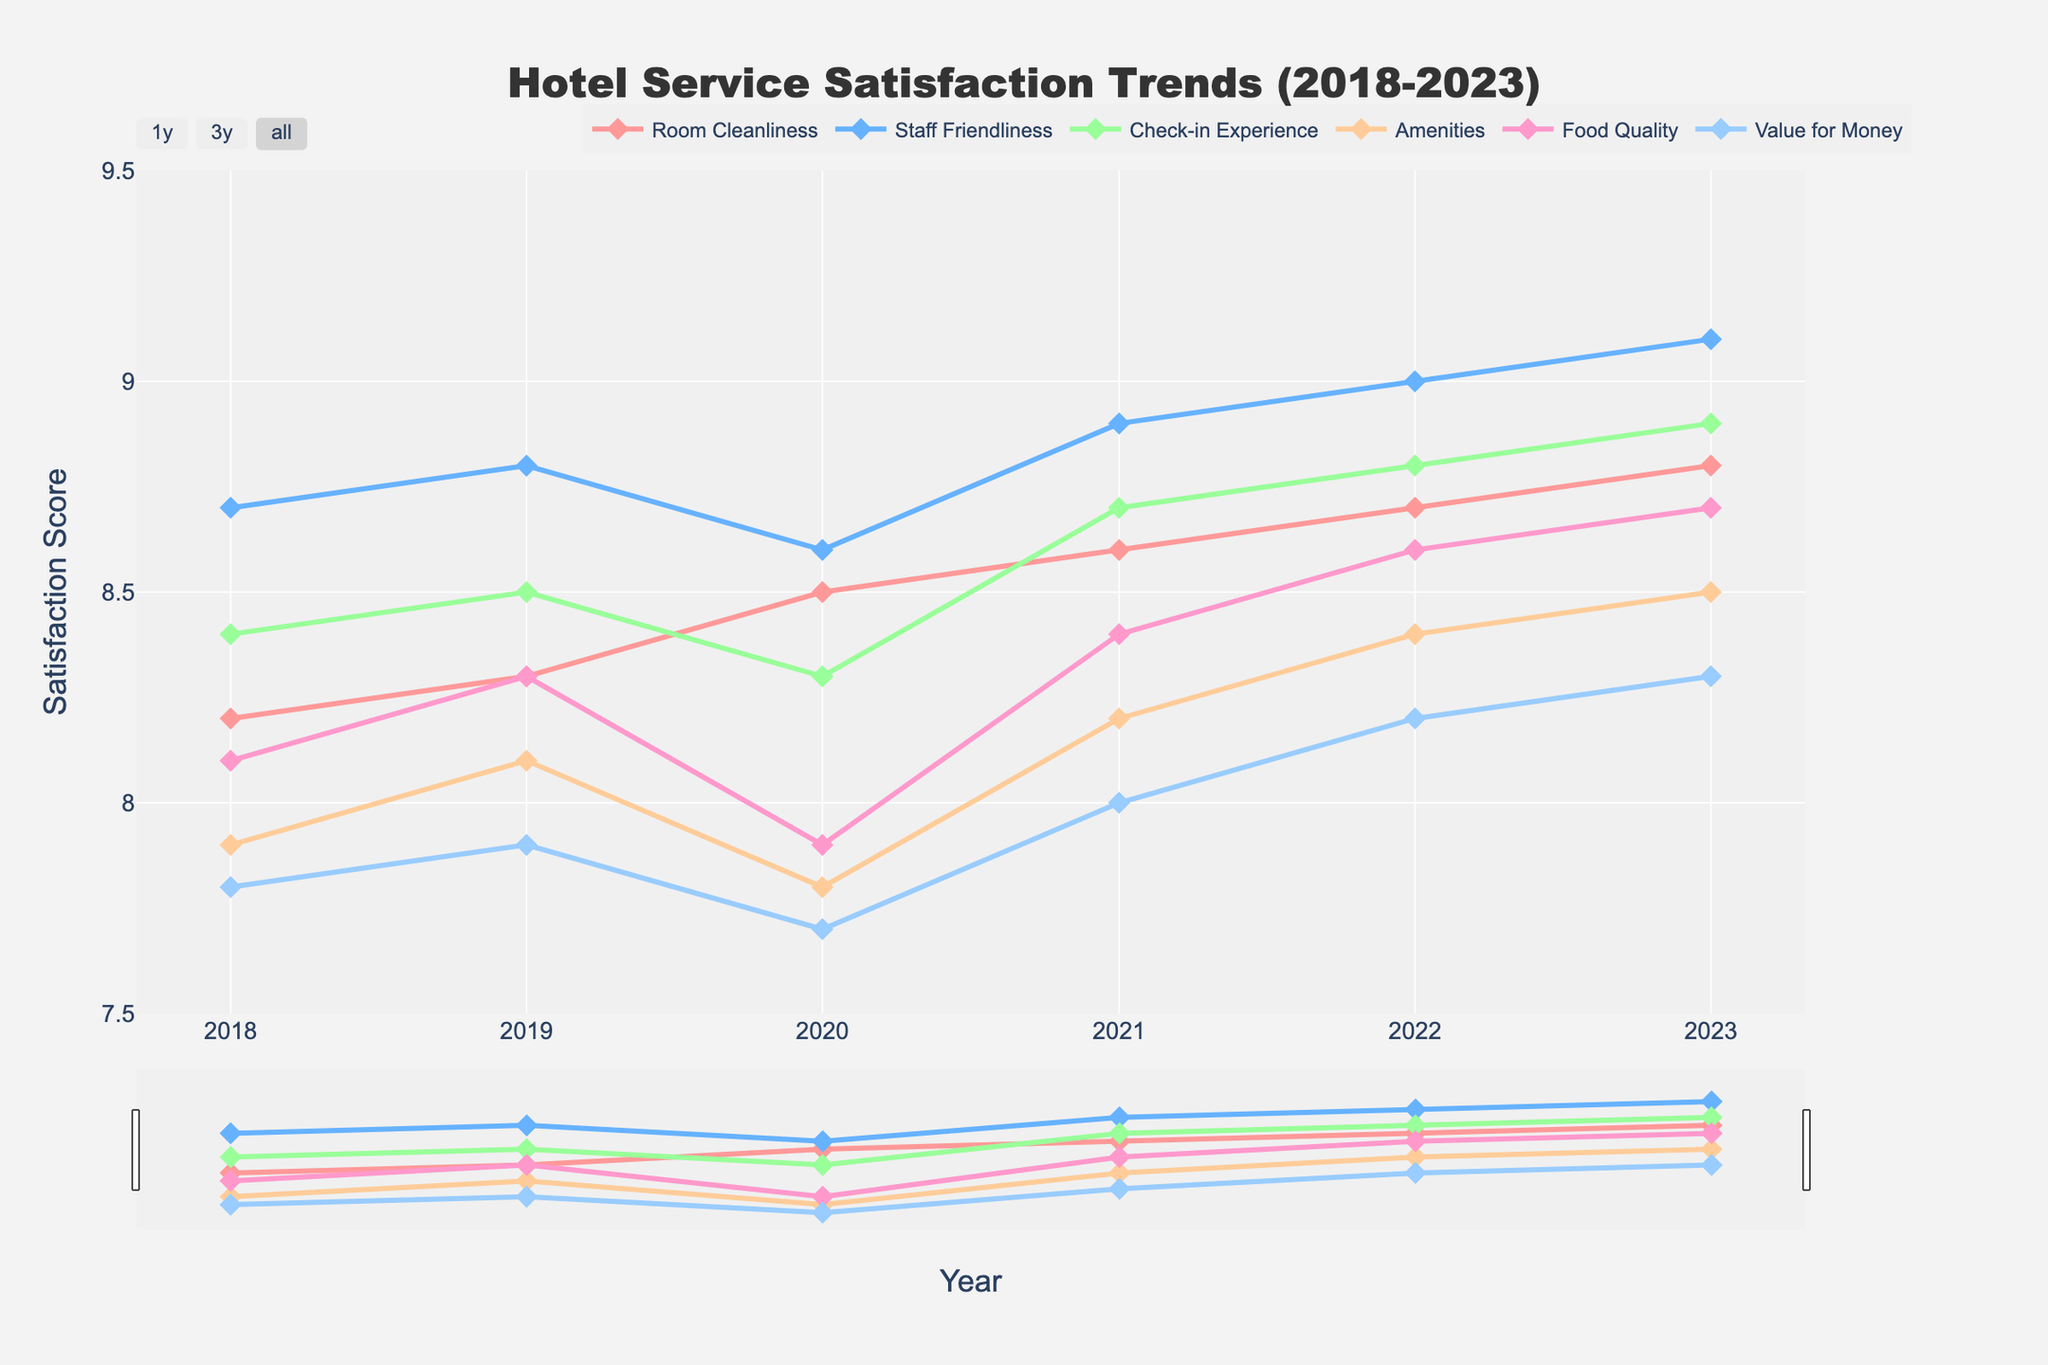How has the satisfaction score for "Room Cleanliness" changed from 2018 to 2023? To find out how the satisfaction score for "Room Cleanliness" has changed, refer to the data points for this aspect from 2018 to 2023. In 2018, the score was 8.2, and by 2023, it had increased to 8.8.
Answer: The satisfaction score for "Room Cleanliness" has increased from 8.2 to 8.8 Which aspect of hotel service had the highest satisfaction score in 2023? Look at the scores for all aspects in the year 2023. The scores are: Room Cleanliness (8.8), Staff Friendliness (9.1), Check-in Experience (8.9), Amenities (8.5), Food Quality (8.7), and Value for Money (8.3). The highest score is 9.1 for "Staff Friendliness".
Answer: Staff Friendliness What is the average satisfaction score for "Food Quality" over the years 2018 to 2023? Add the yearly satisfaction scores for "Food Quality" and divide by the number of years. The scores are: 8.1 (2018), 8.3 (2019), 7.9 (2020), 8.4 (2021), 8.6 (2022), and 8.7 (2023). The sum is 50 and there are 6 years: 50/6 = 8.33.
Answer: 8.33 Did the satisfaction score for "Value for Money" ever decrease compared to the previous year? Check the scores for "Value for Money" year by year to see if any score is lower than the previous year's score. The scores are: 7.8 (2018), 7.9 (2019), 7.7 (2020), 8.0 (2021), 8.2 (2022), 8.3 (2023). The score decreased from 7.9 in 2019 to 7.7 in 2020.
Answer: Yes, it decreased in 2020 Which year saw the greatest improvement in "Check-in Experience"? To determine the greatest improvement, calculate the year-over-year changes for "Check-in Experience". The changes are: (8.5 - 8.4) = 0.1 (2019), (8.3 - 8.5) = -0.2 (2020), (8.7 - 8.3) = 0.4 (2021), (8.8 - 8.7) = 0.1 (2022), (8.9 - 8.8) = 0.1 (2023). The greatest improvement is 0.4 in 2021.
Answer: 2021 Compare the trend for "Staff Friendliness" with that of "Amenities" from 2018 to 2023. Observe both trends over the given years. "Staff Friendliness" shows consistent improvement from 8.7 to 9.1 while "Amenities" fluctuates, starting at 7.9, increasing to 8.4 by 2022, and slightly increasing to 8.5 by 2023.
Answer: "Staff Friendliness" consistently increased while "Amenities" had fluctuations What is the overall trend observed in satisfaction scores from 2018 to 2023? Examine the general movement of all the satisfaction scores. Most aspects show a positive trend with scores gradually increasing over the years, although some fluctuations are present, particularly in 2020.
Answer: Increasing trend Which aspect had the most improvement in satisfaction from its lowest to highest score between 2018 and 2023? Calculate the difference between the lowest and highest score for each aspect. "Room Cleanliness": 8.8 - 8.2 = 0.6, "Staff Friendliness": 9.1 - 8.6 = 0.5, "Check-in Experience": 8.9 - 8.3 = 0.6, "Amenities": 8.5 - 7.8 = 0.7, "Food Quality": 8.7 - 7.9 = 0.8, "Value for Money": 8.3 - 7.7 = 0.6. "Food Quality" had the most improvement with 0.8.
Answer: Food Quality What was the satisfaction score for "Awards and Recognition" in 2021? The given data does not include "Awards and Recognition" as one of the aspects of hotel service satisfaction. Therefore, this aspect cannot be determined from the provided data.
Answer: Data not available Which aspect had the smallest change in satisfaction score between 2018 and 2023? Calculate the differences between 2018 and 2023 scores for each aspect. "Room Cleanliness": 8.8 - 8.2 = 0.6, "Staff Friendliness": 9.1 - 8.7 = 0.4, "Check-in Experience": 8.9 - 8.4 = 0.5, "Amenities": 8.5 - 7.9 = 0.6, "Food Quality": 8.7 - 8.1 = 0.6, "Value for Money": 8.3 - 7.8 = 0.5. "Staff Friendliness" had the smallest change with 0.4.
Answer: Staff Friendliness 